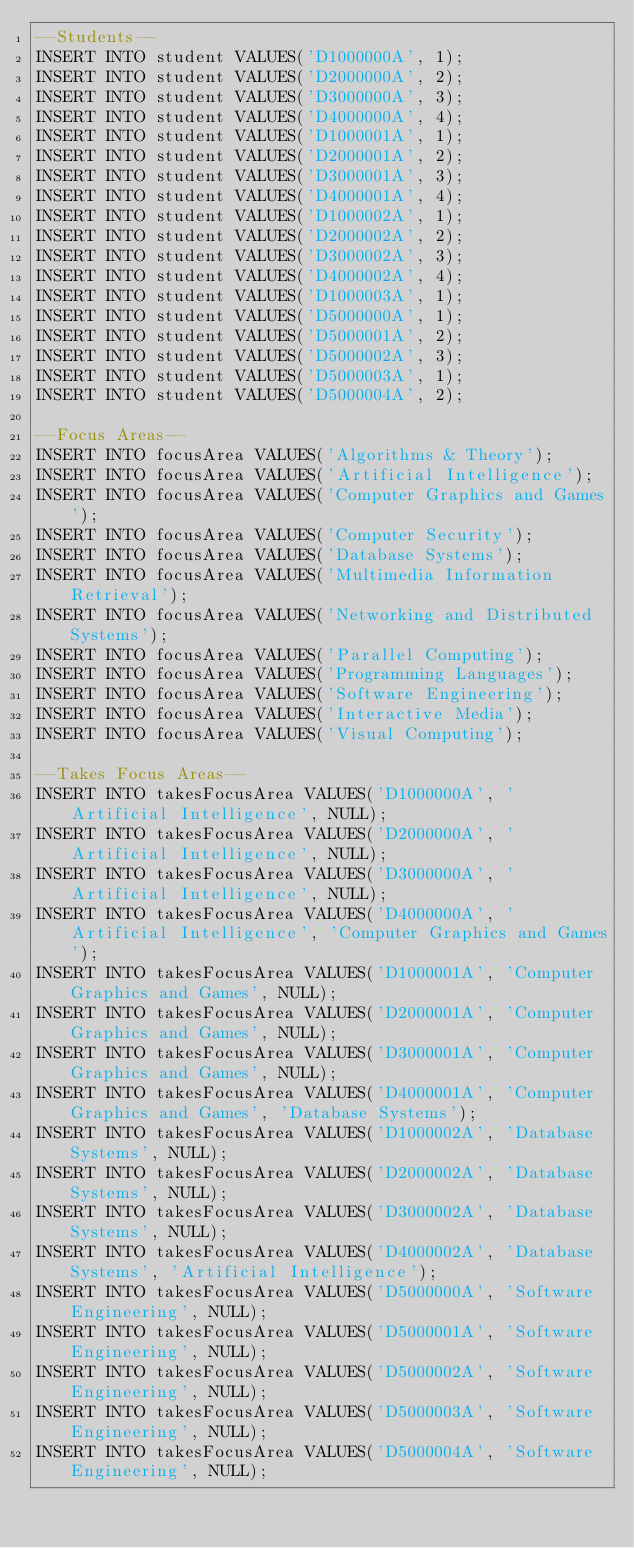<code> <loc_0><loc_0><loc_500><loc_500><_SQL_>--Students--
INSERT INTO student VALUES('D1000000A', 1);
INSERT INTO student VALUES('D2000000A', 2);
INSERT INTO student VALUES('D3000000A', 3);
INSERT INTO student VALUES('D4000000A', 4);
INSERT INTO student VALUES('D1000001A', 1);
INSERT INTO student VALUES('D2000001A', 2);
INSERT INTO student VALUES('D3000001A', 3);
INSERT INTO student VALUES('D4000001A', 4);
INSERT INTO student VALUES('D1000002A', 1);
INSERT INTO student VALUES('D2000002A', 2);
INSERT INTO student VALUES('D3000002A', 3);
INSERT INTO student VALUES('D4000002A', 4);
INSERT INTO student VALUES('D1000003A', 1);
INSERT INTO student VALUES('D5000000A', 1);
INSERT INTO student VALUES('D5000001A', 2);
INSERT INTO student VALUES('D5000002A', 3);
INSERT INTO student VALUES('D5000003A', 1);
INSERT INTO student VALUES('D5000004A', 2);

--Focus Areas--
INSERT INTO focusArea VALUES('Algorithms & Theory');
INSERT INTO focusArea VALUES('Artificial Intelligence');
INSERT INTO focusArea VALUES('Computer Graphics and Games');
INSERT INTO focusArea VALUES('Computer Security');
INSERT INTO focusArea VALUES('Database Systems');
INSERT INTO focusArea VALUES('Multimedia Information Retrieval');
INSERT INTO focusArea VALUES('Networking and Distributed Systems');
INSERT INTO focusArea VALUES('Parallel Computing');
INSERT INTO focusArea VALUES('Programming Languages');
INSERT INTO focusArea VALUES('Software Engineering');
INSERT INTO focusArea VALUES('Interactive Media');
INSERT INTO focusArea VALUES('Visual Computing');

--Takes Focus Areas--
INSERT INTO takesFocusArea VALUES('D1000000A', 'Artificial Intelligence', NULL);
INSERT INTO takesFocusArea VALUES('D2000000A', 'Artificial Intelligence', NULL);
INSERT INTO takesFocusArea VALUES('D3000000A', 'Artificial Intelligence', NULL);
INSERT INTO takesFocusArea VALUES('D4000000A', 'Artificial Intelligence', 'Computer Graphics and Games');
INSERT INTO takesFocusArea VALUES('D1000001A', 'Computer Graphics and Games', NULL);
INSERT INTO takesFocusArea VALUES('D2000001A', 'Computer Graphics and Games', NULL);
INSERT INTO takesFocusArea VALUES('D3000001A', 'Computer Graphics and Games', NULL);
INSERT INTO takesFocusArea VALUES('D4000001A', 'Computer Graphics and Games', 'Database Systems');
INSERT INTO takesFocusArea VALUES('D1000002A', 'Database Systems', NULL);
INSERT INTO takesFocusArea VALUES('D2000002A', 'Database Systems', NULL);
INSERT INTO takesFocusArea VALUES('D3000002A', 'Database Systems', NULL);
INSERT INTO takesFocusArea VALUES('D4000002A', 'Database Systems', 'Artificial Intelligence');
INSERT INTO takesFocusArea VALUES('D5000000A', 'Software Engineering', NULL);
INSERT INTO takesFocusArea VALUES('D5000001A', 'Software Engineering', NULL);
INSERT INTO takesFocusArea VALUES('D5000002A', 'Software Engineering', NULL);
INSERT INTO takesFocusArea VALUES('D5000003A', 'Software Engineering', NULL);
INSERT INTO takesFocusArea VALUES('D5000004A', 'Software Engineering', NULL);
</code> 